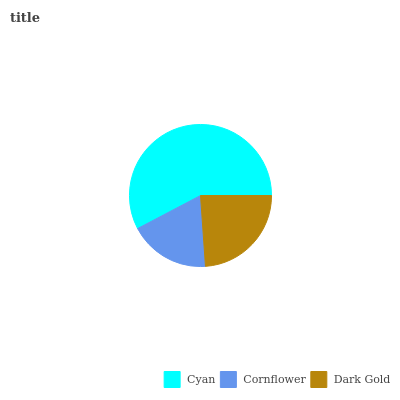Is Cornflower the minimum?
Answer yes or no. Yes. Is Cyan the maximum?
Answer yes or no. Yes. Is Dark Gold the minimum?
Answer yes or no. No. Is Dark Gold the maximum?
Answer yes or no. No. Is Dark Gold greater than Cornflower?
Answer yes or no. Yes. Is Cornflower less than Dark Gold?
Answer yes or no. Yes. Is Cornflower greater than Dark Gold?
Answer yes or no. No. Is Dark Gold less than Cornflower?
Answer yes or no. No. Is Dark Gold the high median?
Answer yes or no. Yes. Is Dark Gold the low median?
Answer yes or no. Yes. Is Cyan the high median?
Answer yes or no. No. Is Cyan the low median?
Answer yes or no. No. 